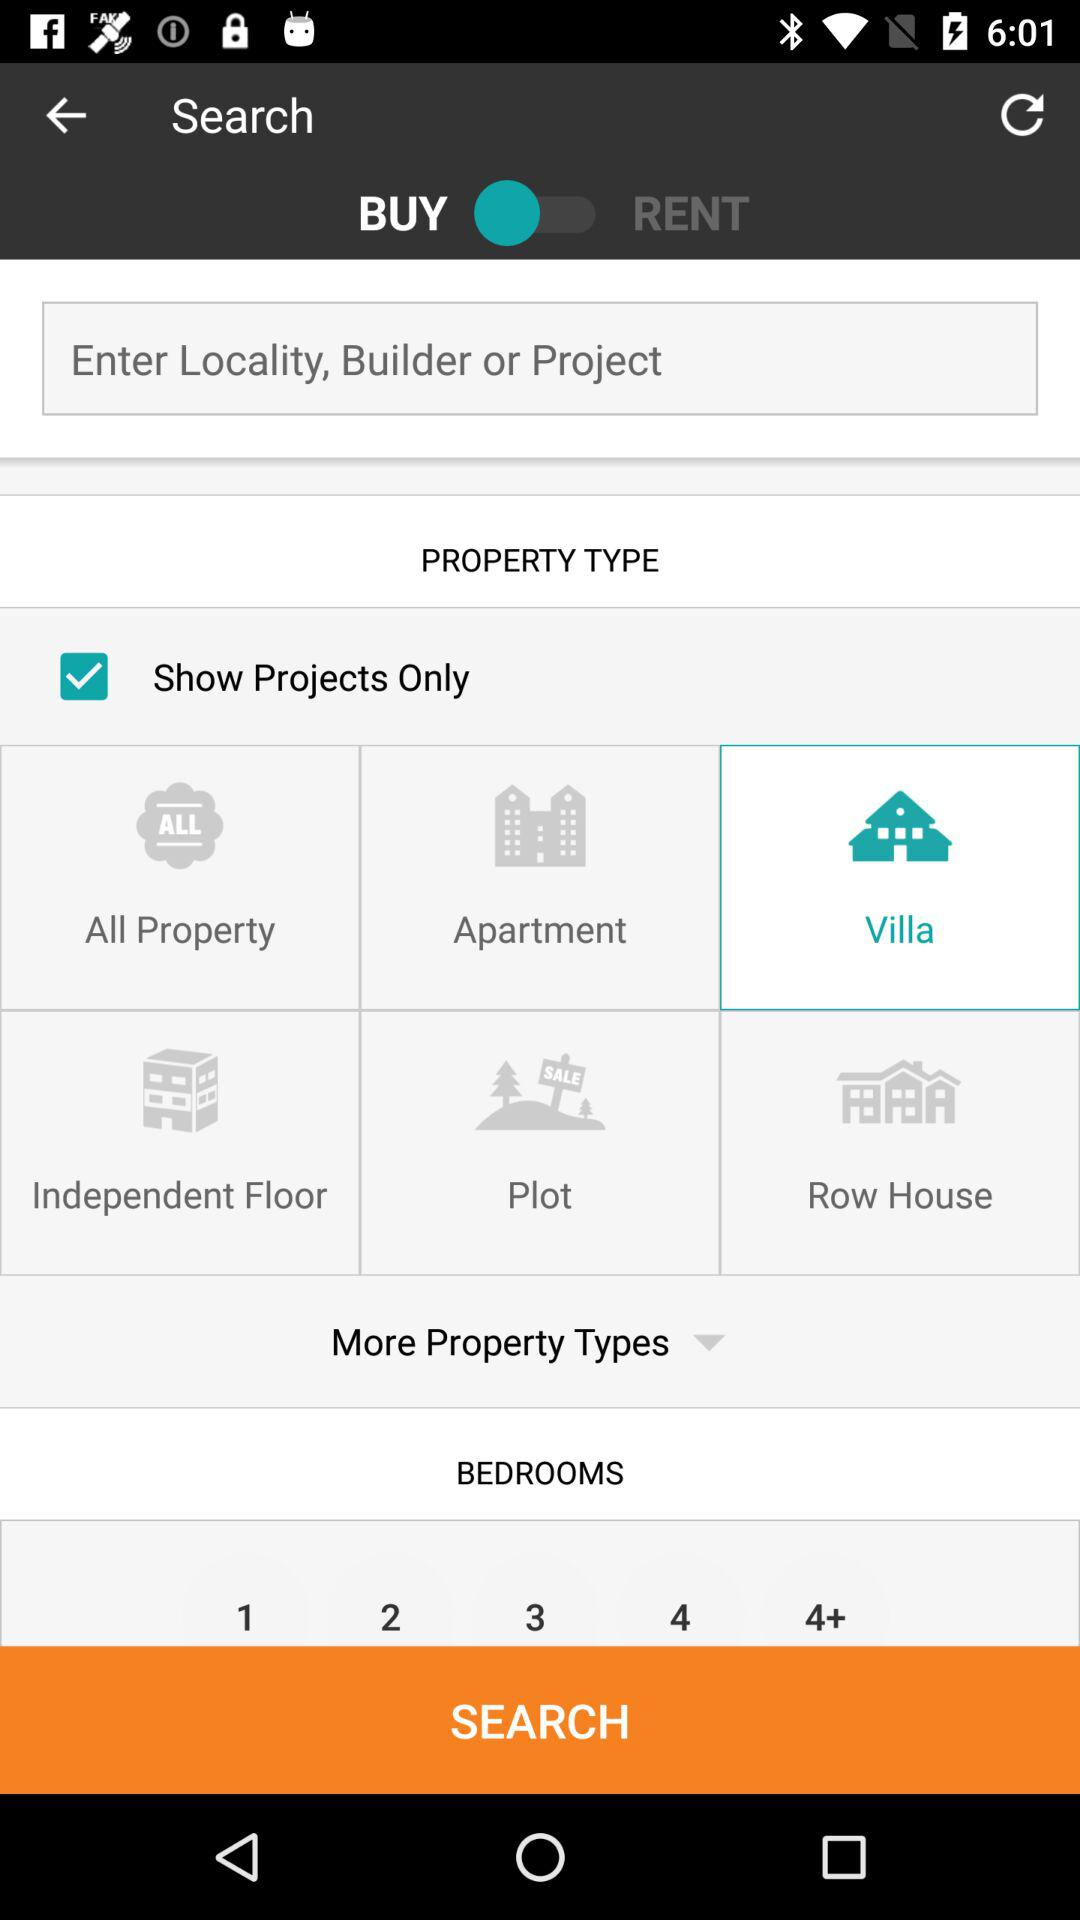What is the status of the "Show Projects Only"? The status is "on". 